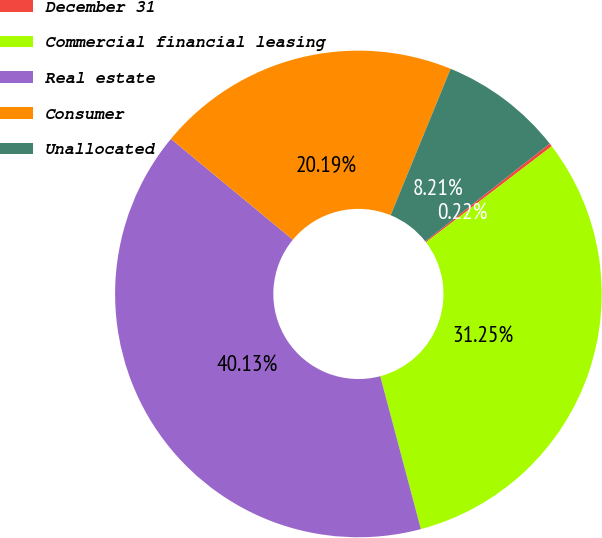<chart> <loc_0><loc_0><loc_500><loc_500><pie_chart><fcel>December 31<fcel>Commercial financial leasing<fcel>Real estate<fcel>Consumer<fcel>Unallocated<nl><fcel>0.22%<fcel>31.25%<fcel>40.13%<fcel>20.19%<fcel>8.21%<nl></chart> 